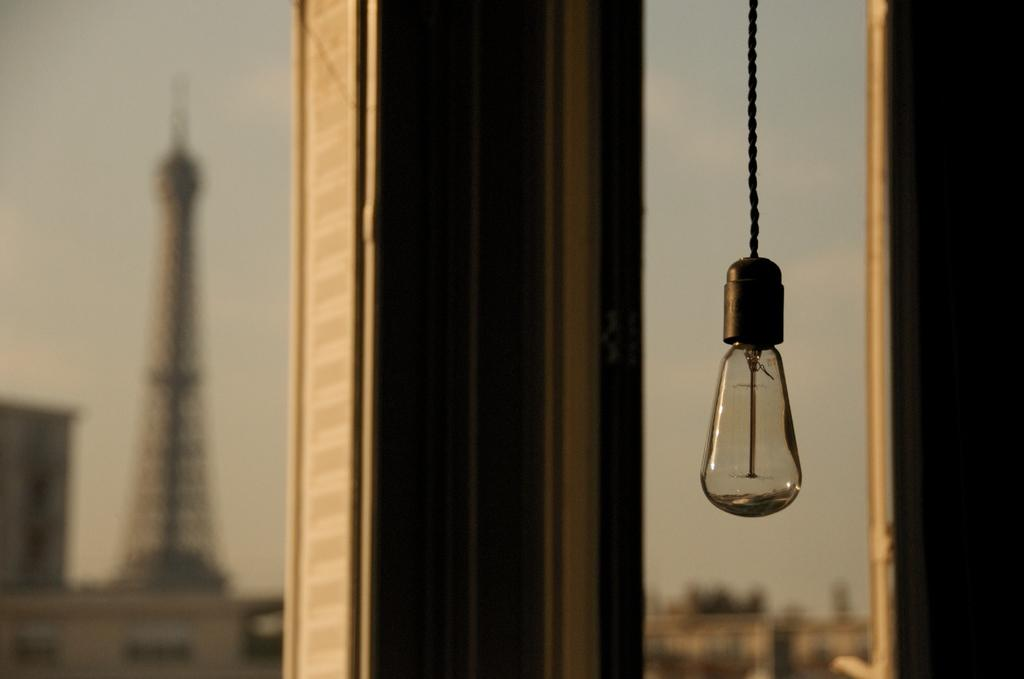What object can be seen in the image that provides light? There is a bulb in the image that provides light. What tall structure is present in the image? There is a tower in the image. What type of man-made structures are visible in the image? There are buildings in the image. What type of vegetation can be seen in the image? There are trees in the image. What is visible in the background of the image? The sky is visible in the background of the image. What day of the week is depicted in the image? The image does not depict a day of the week; it shows a bulb, a tower, buildings, trees, and the sky. What type of cooking utensil can be seen in the image? There is no cooking utensil present in the image. 